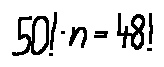Convert formula to latex. <formula><loc_0><loc_0><loc_500><loc_500>5 0 ! \cdot n = 4 8 !</formula> 